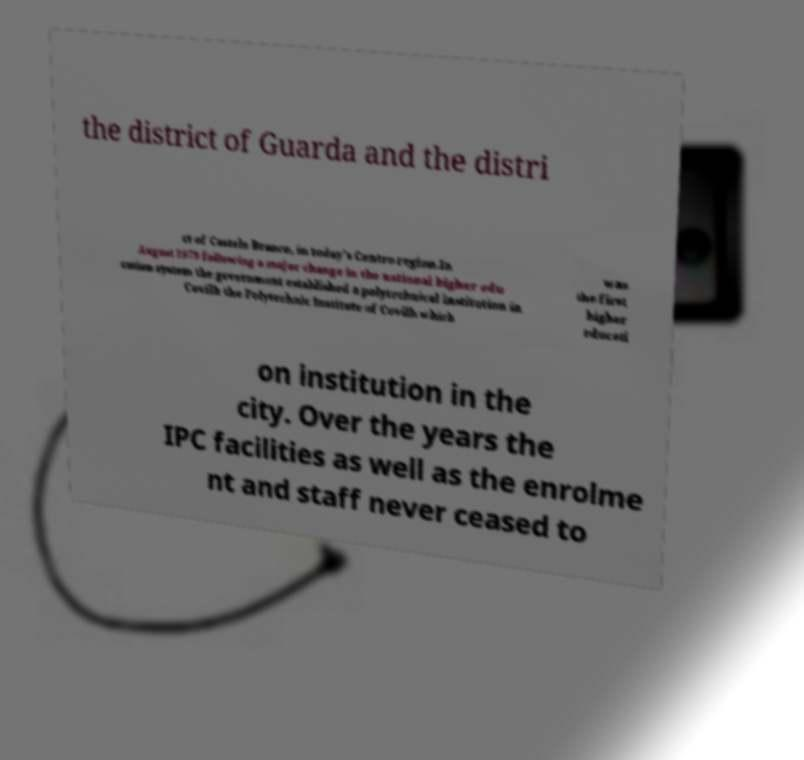Please identify and transcribe the text found in this image. the district of Guarda and the distri ct of Castelo Branco, in today's Centro region.In August 1973 following a major change in the national higher edu cation system the government established a polytechnical institution in Covilh the Polytechnic Institute of Covilh which was the first higher educati on institution in the city. Over the years the IPC facilities as well as the enrolme nt and staff never ceased to 